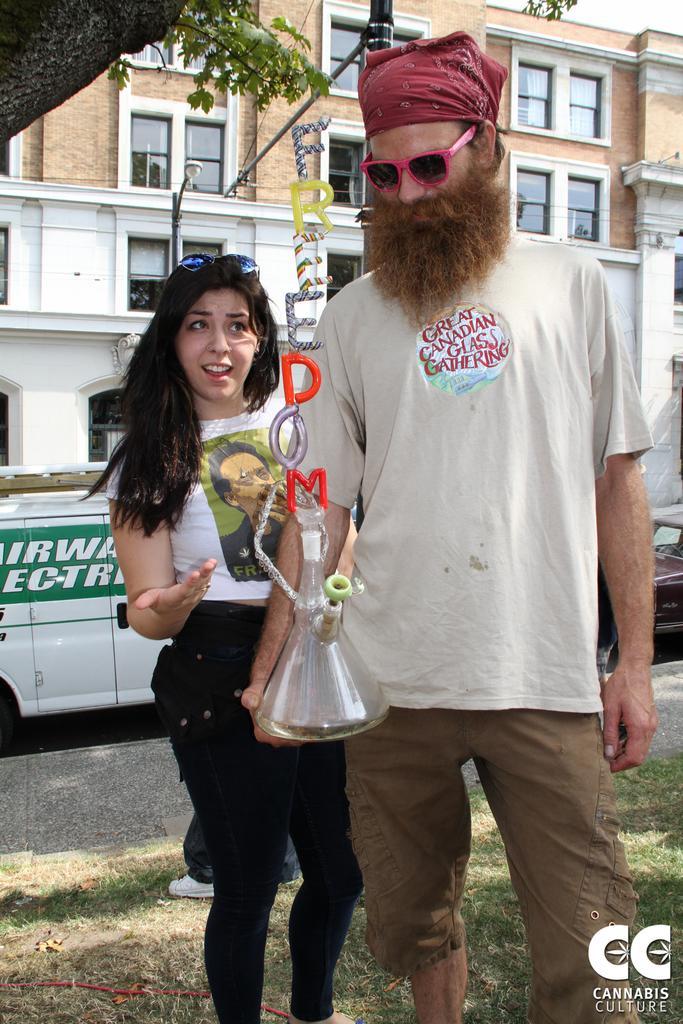Could you give a brief overview of what you see in this image? In this picture we can see a man standing on the grass ground and holding something made of glass. On the left side, we can see a woman standing and looking at him. In the background, we can see vehicles and buildings. 